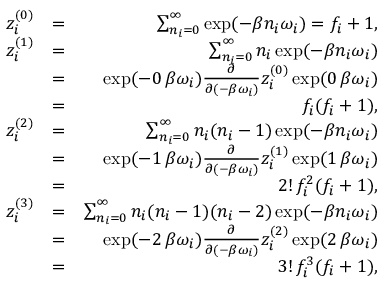<formula> <loc_0><loc_0><loc_500><loc_500>\begin{array} { r l r } { z _ { i } ^ { ( 0 ) } } & { = } & { \sum _ { n _ { i } = 0 } ^ { \infty } \exp ( - \beta n _ { i } \omega _ { i } ) = f _ { i } + 1 , } \\ { z _ { i } ^ { ( 1 ) } } & { = } & { \sum _ { n _ { i } = 0 } ^ { \infty } n _ { i } \exp ( - \beta n _ { i } \omega _ { i } ) } \\ & { = } & { \exp ( - 0 \, \beta \omega _ { i } ) \frac { \partial } { \partial ( - \beta \omega _ { i } ) } z _ { i } ^ { ( 0 ) } \exp ( 0 \, \beta \omega _ { i } ) } \\ & { = } & { f _ { i } ( f _ { i } + 1 ) , } \\ { z _ { i } ^ { ( 2 ) } } & { = } & { \sum _ { n _ { i } = 0 } ^ { \infty } n _ { i } ( n _ { i } - 1 ) \exp ( - \beta n _ { i } \omega _ { i } ) } \\ & { = } & { \exp ( - 1 \, \beta \omega _ { i } ) \frac { \partial } { \partial ( - \beta \omega _ { i } ) } z _ { i } ^ { ( 1 ) } \exp ( 1 \, \beta \omega _ { i } ) } \\ & { = } & { 2 ! \, f _ { i } ^ { 2 } ( f _ { i } + 1 ) , } \\ { z _ { i } ^ { ( 3 ) } } & { = } & { \sum _ { n _ { i } = 0 } ^ { \infty } n _ { i } ( n _ { i } - 1 ) ( n _ { i } - 2 ) \exp ( - \beta n _ { i } \omega _ { i } ) } \\ & { = } & { \exp ( - 2 \, \beta \omega _ { i } ) \frac { \partial } { \partial ( - \beta \omega _ { i } ) } z _ { i } ^ { ( 2 ) } \exp ( 2 \, \beta \omega _ { i } ) } \\ & { = } & { 3 ! \, f _ { i } ^ { 3 } ( f _ { i } + 1 ) , } \end{array}</formula> 